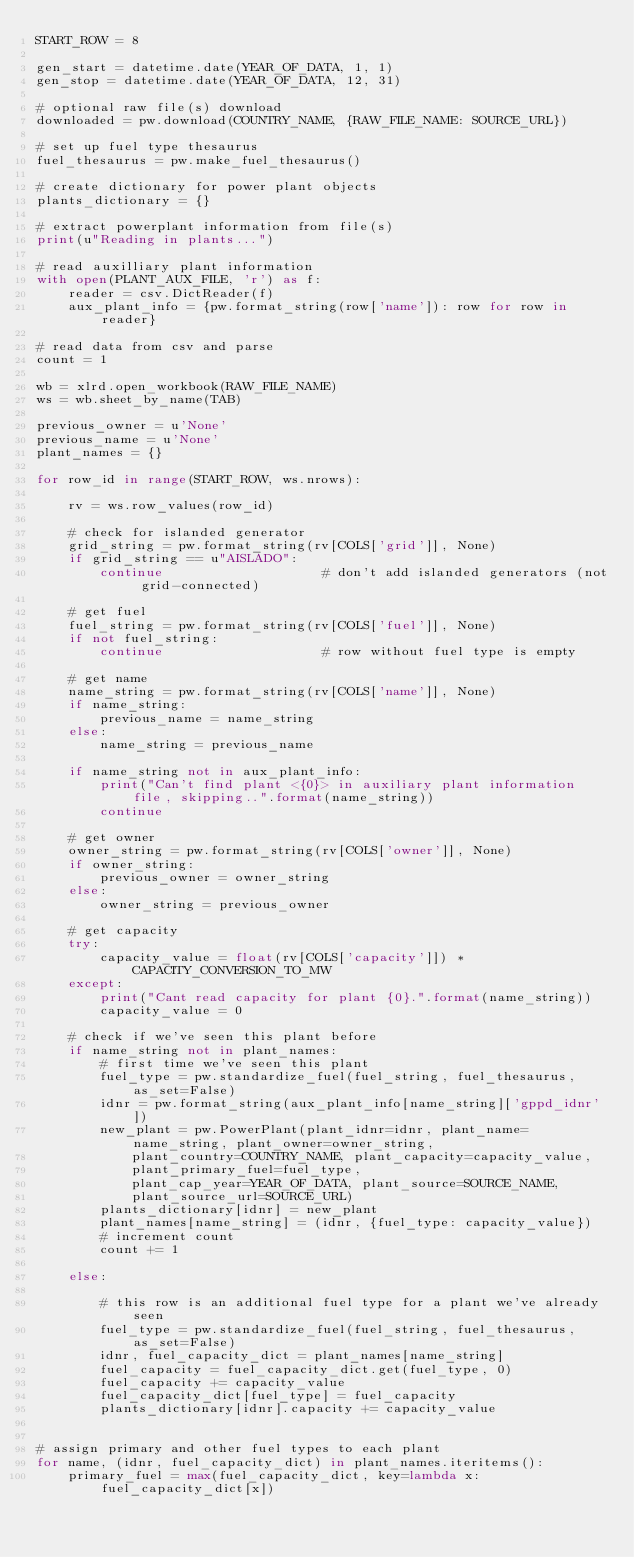<code> <loc_0><loc_0><loc_500><loc_500><_Python_>START_ROW = 8

gen_start = datetime.date(YEAR_OF_DATA, 1, 1)
gen_stop = datetime.date(YEAR_OF_DATA, 12, 31)

# optional raw file(s) download
downloaded = pw.download(COUNTRY_NAME, {RAW_FILE_NAME: SOURCE_URL})

# set up fuel type thesaurus
fuel_thesaurus = pw.make_fuel_thesaurus()

# create dictionary for power plant objects
plants_dictionary = {}

# extract powerplant information from file(s)
print(u"Reading in plants...")

# read auxilliary plant information
with open(PLANT_AUX_FILE, 'r') as f:
    reader = csv.DictReader(f)
    aux_plant_info = {pw.format_string(row['name']): row for row in reader}

# read data from csv and parse
count = 1

wb = xlrd.open_workbook(RAW_FILE_NAME)
ws = wb.sheet_by_name(TAB)

previous_owner = u'None'
previous_name = u'None'
plant_names = {}

for row_id in range(START_ROW, ws.nrows):

    rv = ws.row_values(row_id) 

    # check for islanded generator
    grid_string = pw.format_string(rv[COLS['grid']], None)
    if grid_string == u"AISLADO":
        continue                    # don't add islanded generators (not grid-connected)

    # get fuel
    fuel_string = pw.format_string(rv[COLS['fuel']], None)
    if not fuel_string:
        continue                    # row without fuel type is empty

    # get name
    name_string = pw.format_string(rv[COLS['name']], None)
    if name_string:
        previous_name = name_string
    else:
        name_string = previous_name

    if name_string not in aux_plant_info:
        print("Can't find plant <{0}> in auxiliary plant information file, skipping..".format(name_string))
        continue

    # get owner
    owner_string = pw.format_string(rv[COLS['owner']], None)
    if owner_string:
        previous_owner = owner_string
    else:
        owner_string = previous_owner

    # get capacity
    try:
        capacity_value = float(rv[COLS['capacity']]) * CAPACITY_CONVERSION_TO_MW
    except:
        print("Cant read capacity for plant {0}.".format(name_string))
        capacity_value = 0

    # check if we've seen this plant before
    if name_string not in plant_names:
        # first time we've seen this plant
        fuel_type = pw.standardize_fuel(fuel_string, fuel_thesaurus, as_set=False)
        idnr = pw.format_string(aux_plant_info[name_string]['gppd_idnr'])
        new_plant = pw.PowerPlant(plant_idnr=idnr, plant_name=name_string, plant_owner=owner_string,
            plant_country=COUNTRY_NAME, plant_capacity=capacity_value,
            plant_primary_fuel=fuel_type,
            plant_cap_year=YEAR_OF_DATA, plant_source=SOURCE_NAME, 
            plant_source_url=SOURCE_URL)
        plants_dictionary[idnr] = new_plant
        plant_names[name_string] = (idnr, {fuel_type: capacity_value})
        # increment count
        count += 1

    else:

        # this row is an additional fuel type for a plant we've already seen
        fuel_type = pw.standardize_fuel(fuel_string, fuel_thesaurus, as_set=False)
        idnr, fuel_capacity_dict = plant_names[name_string]
        fuel_capacity = fuel_capacity_dict.get(fuel_type, 0)
        fuel_capacity += capacity_value
        fuel_capacity_dict[fuel_type] = fuel_capacity
        plants_dictionary[idnr].capacity += capacity_value


# assign primary and other fuel types to each plant
for name, (idnr, fuel_capacity_dict) in plant_names.iteritems():
    primary_fuel = max(fuel_capacity_dict, key=lambda x: fuel_capacity_dict[x])</code> 